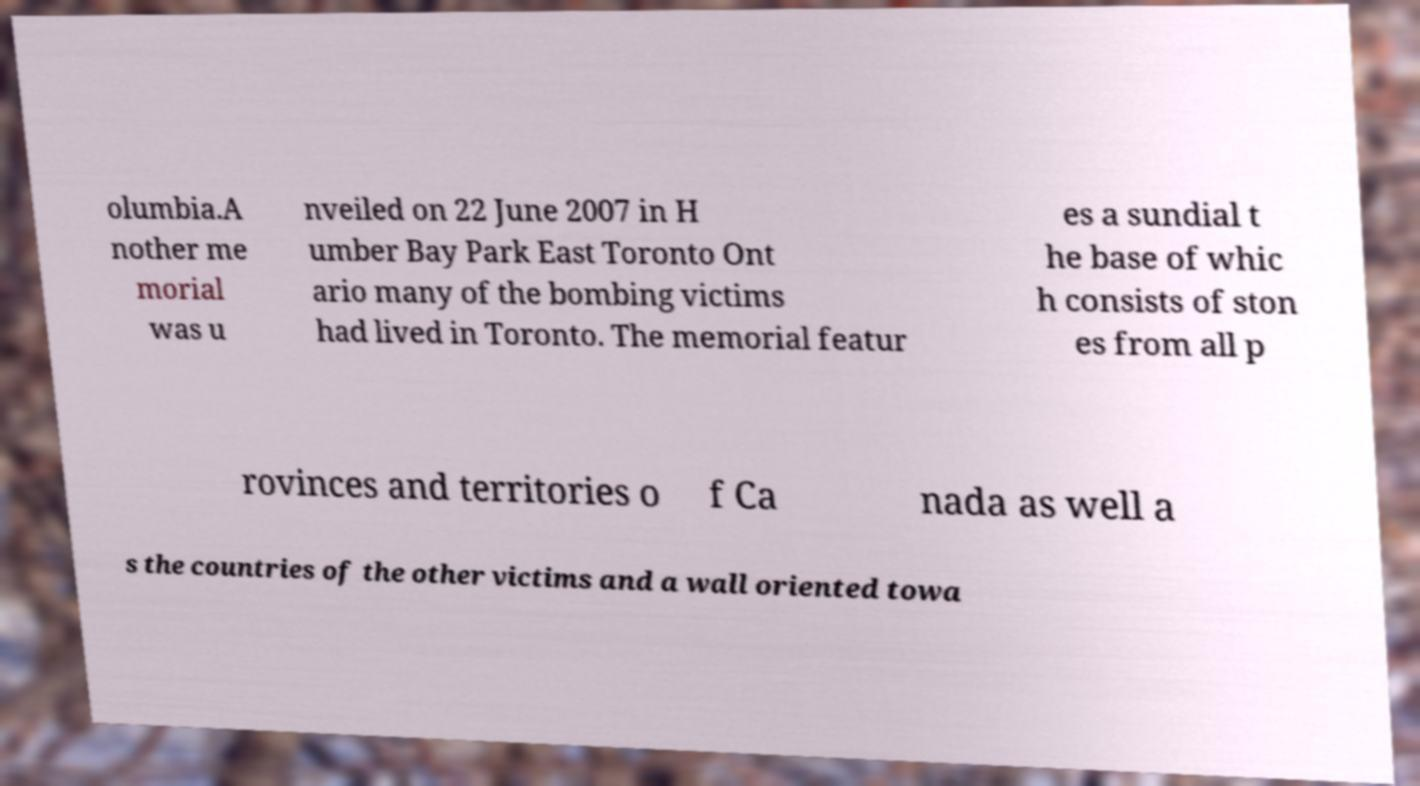What messages or text are displayed in this image? I need them in a readable, typed format. olumbia.A nother me morial was u nveiled on 22 June 2007 in H umber Bay Park East Toronto Ont ario many of the bombing victims had lived in Toronto. The memorial featur es a sundial t he base of whic h consists of ston es from all p rovinces and territories o f Ca nada as well a s the countries of the other victims and a wall oriented towa 